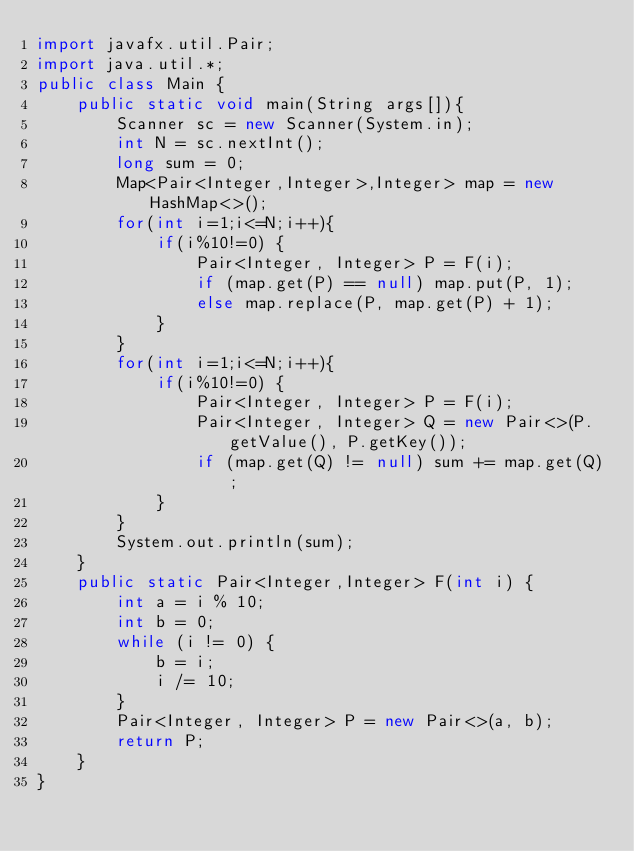<code> <loc_0><loc_0><loc_500><loc_500><_Java_>import javafx.util.Pair;
import java.util.*;
public class Main {
    public static void main(String args[]){
        Scanner sc = new Scanner(System.in);
        int N = sc.nextInt();
        long sum = 0;
        Map<Pair<Integer,Integer>,Integer> map = new HashMap<>();
        for(int i=1;i<=N;i++){
            if(i%10!=0) {
                Pair<Integer, Integer> P = F(i);
                if (map.get(P) == null) map.put(P, 1);
                else map.replace(P, map.get(P) + 1);
            }
        }
        for(int i=1;i<=N;i++){
            if(i%10!=0) {
                Pair<Integer, Integer> P = F(i);
                Pair<Integer, Integer> Q = new Pair<>(P.getValue(), P.getKey());
                if (map.get(Q) != null) sum += map.get(Q);
            }
        }
        System.out.println(sum);
    }
    public static Pair<Integer,Integer> F(int i) {
        int a = i % 10;
        int b = 0;
        while (i != 0) {
            b = i;
            i /= 10;
        }
        Pair<Integer, Integer> P = new Pair<>(a, b);
        return P;
    }
}</code> 